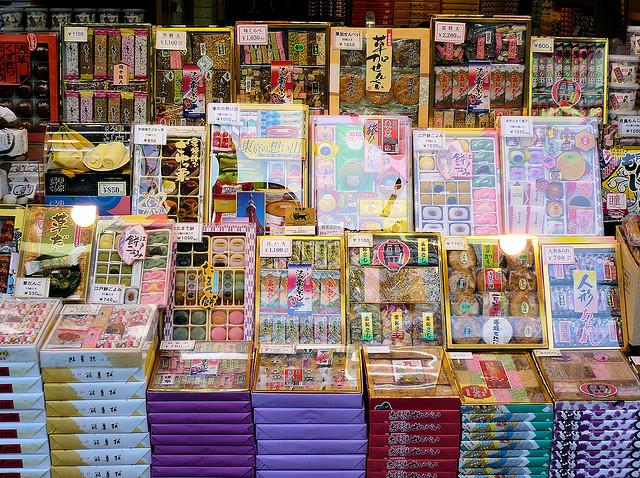Why are the boxes lined up and on display? Please explain your reasoning. to sell. There are many of them and they're located in either a store or market stall. 